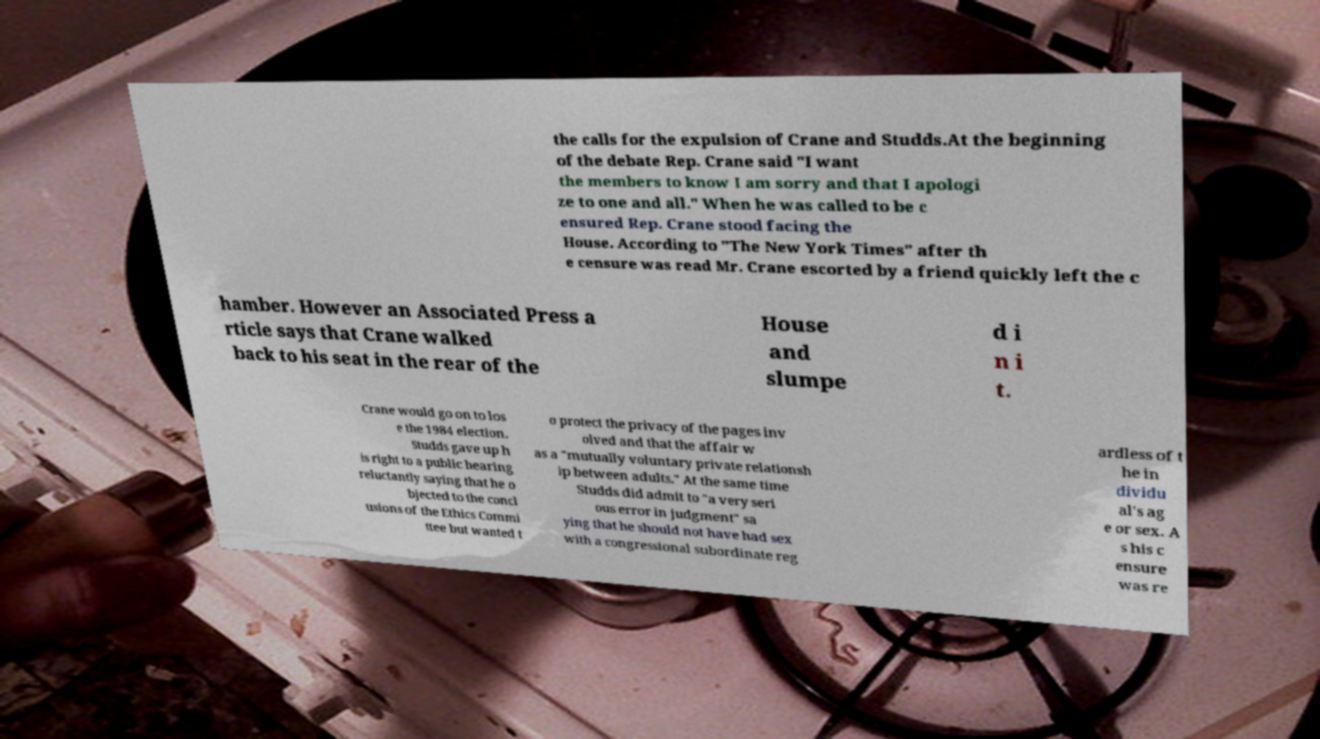I need the written content from this picture converted into text. Can you do that? the calls for the expulsion of Crane and Studds.At the beginning of the debate Rep. Crane said "I want the members to know I am sorry and that I apologi ze to one and all." When he was called to be c ensured Rep. Crane stood facing the House. According to "The New York Times" after th e censure was read Mr. Crane escorted by a friend quickly left the c hamber. However an Associated Press a rticle says that Crane walked back to his seat in the rear of the House and slumpe d i n i t. Crane would go on to los e the 1984 election. Studds gave up h is right to a public hearing reluctantly saying that he o bjected to the concl usions of the Ethics Commi ttee but wanted t o protect the privacy of the pages inv olved and that the affair w as a "mutually voluntary private relationsh ip between adults." At the same time Studds did admit to "a very seri ous error in judgment" sa ying that he should not have had sex with a congressional subordinate reg ardless of t he in dividu al's ag e or sex. A s his c ensure was re 